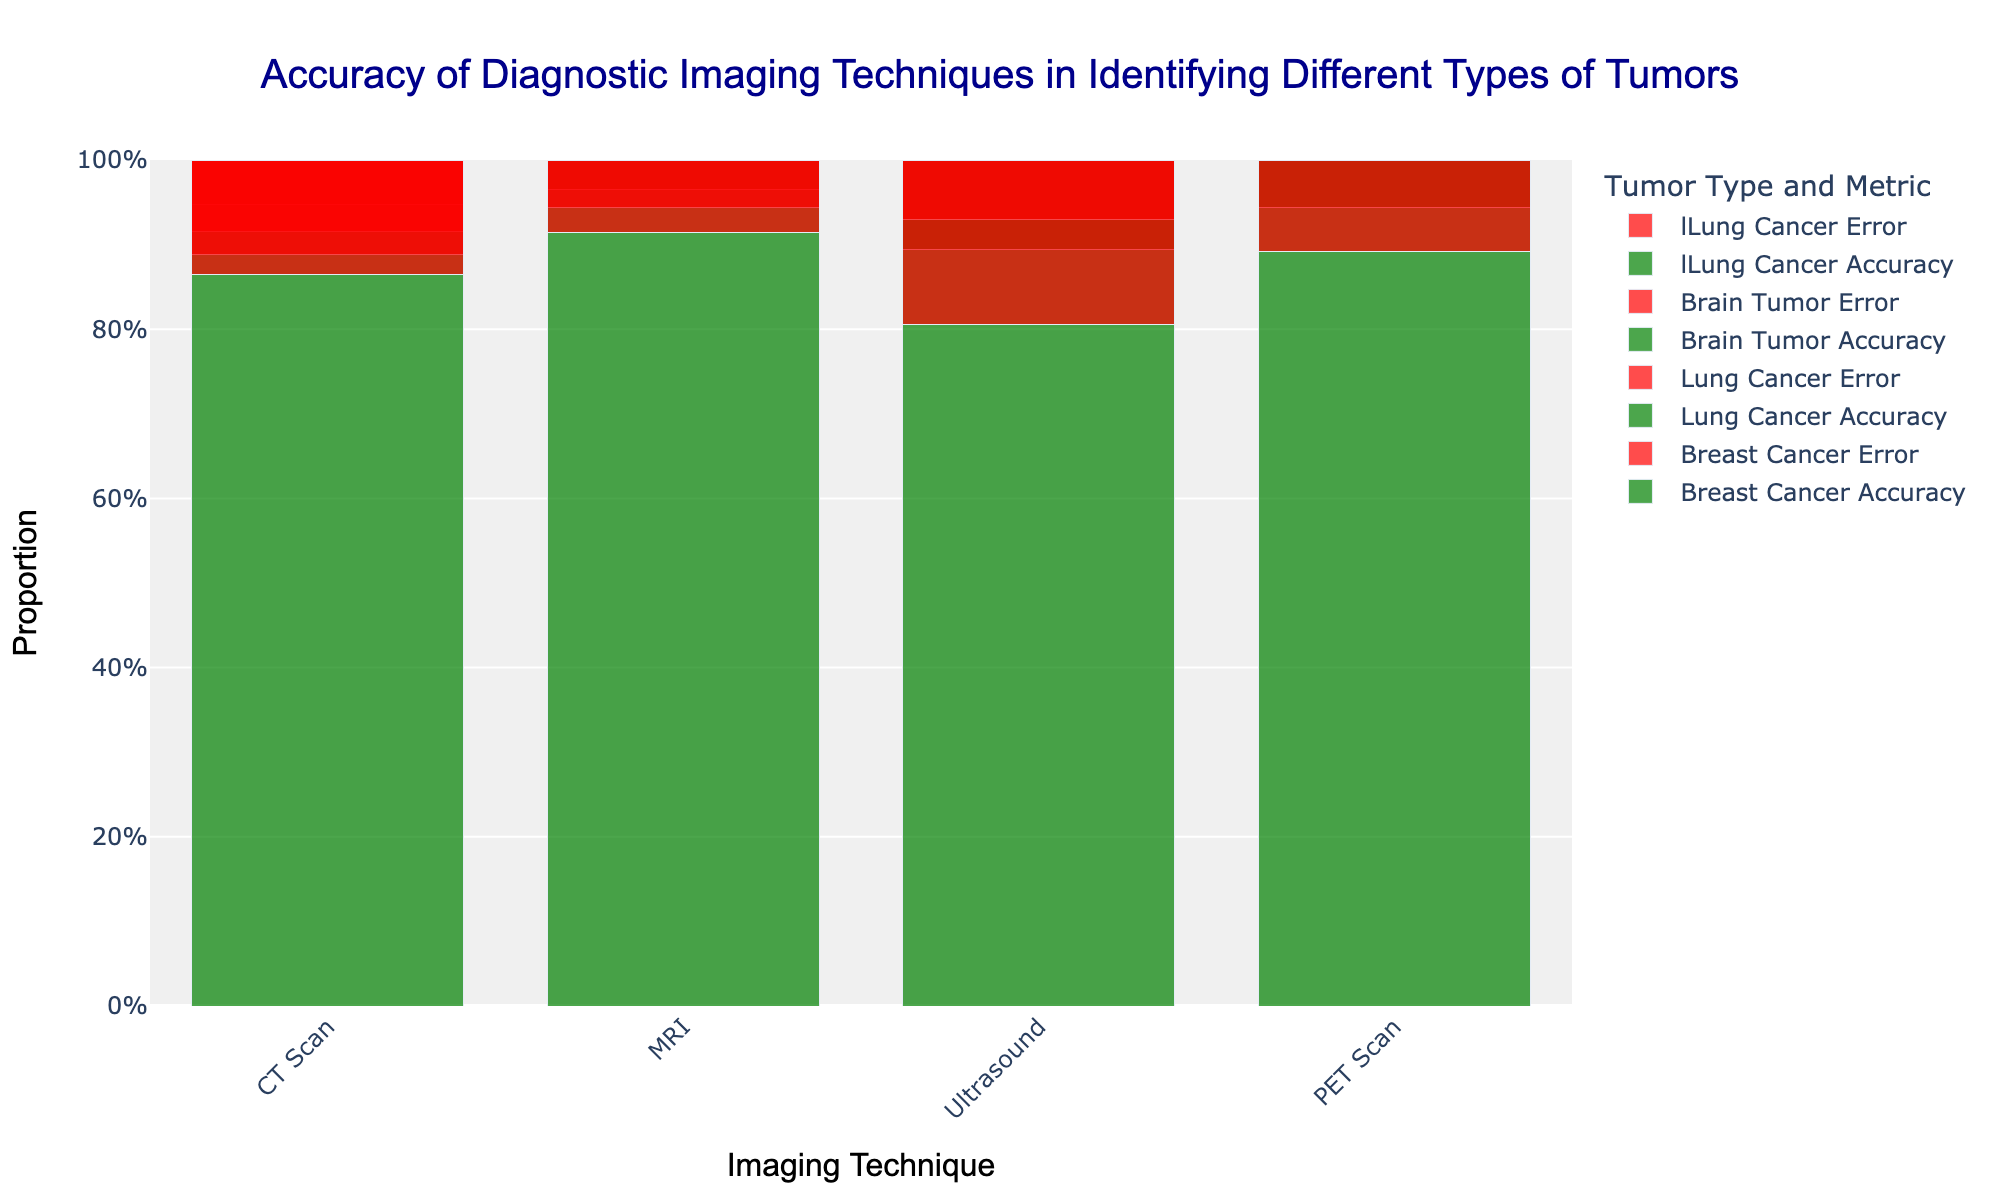Which imaging technique has the highest accuracy for detecting Breast Cancer? The chart shows bars for different imaging techniques and tumor types. For Breast Cancer, the highest bar segment reaching the top indicates the highest accuracy. The MRI technique has the tallest green bar for Breast Cancer.
Answer: MRI How does the accuracy of MRI compare between detecting Lung Cancer and Brain Tumors? Comparing the green bar segments for MRI, the Lung Cancer accuracy bar is taller than the Brain Tumor accuracy bar, indicating higher accuracy.
Answer: MRI is more accurate for Lung Cancer than Brain Tumors Which imaging technique has the lowest accuracy for detecting Lung Cancer? By identifying the smallest green bar for Lung Cancer across different imaging techniques, Ultrasound has the smallest green bar compared to others.
Answer: Ultrasound What's the difference in accuracy between CT Scan and PET Scan for Brain Tumors? The green segments of the bars for CT Scan and PET Scan under Brain Tumor show the proportions. PET Scan has a slightly taller green segment. The difference is the error segment. CT Scan: 0.8 (error) - 0.88 (Bone Scan) => 0.08 difference.
Answer: 0.08 Which imaging technique shows the largest error rate for identifying Breast Cancer? The largest red bar segment for Breast Cancer corresponds to the highest error rate. Ultrasound has the largest red segment for Breast Cancer.
Answer: Ultrasound Are there any imaging techniques where accuracy for one tumor type stands out significantly compared to others? The accuracy for MRI detecting Lung Cancer stands out significantly with a prominent green section relative to other tumor types using the same technique.
Answer: MRI for Lung Cancer What's the average accuracy of CT Scan across all tumor types? Sum the accuracies for Breast Cancer, Lung Cancer, and Brain Tumor for CT Scan. Then, divide by 3:
Breast Cancer (CT): 92.16%
Lung Cancer (CT): 89.58%
Brain Tumor (CT): 80.0%
(0.9216 + 0.8958 + 0.8) / 3 = 0.8725
Answer: 87.25% Compare the visual heights of accuracy for PET Scan between Brain Tumor and Breast Cancer and identify which is more accurate. The comparison of green bar heights for PET Scan across Brain Tumor and Breast Cancer shows Breast Cancer (green bar) is taller than Brain Tumor, indicating higher accuracy for Breast Cancer.
Answer: PET Scan is more accurate for Breast Cancer Which imaging technique reveals a balanced accuracy between all types of tumors? Find a technique with green bars (accuracy) of relatively similar heights for all tumor types. PET Scan displays balanced heights of green bars for all tumor types.
Answer: PET Scan 